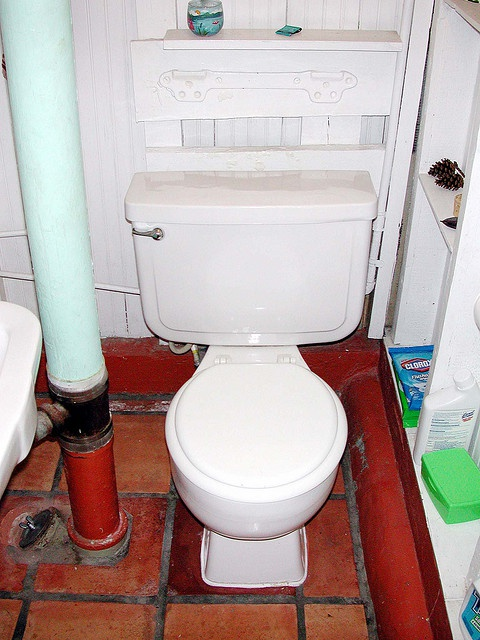Describe the objects in this image and their specific colors. I can see toilet in darkgray and lightgray tones and cup in darkgray, teal, and gray tones in this image. 